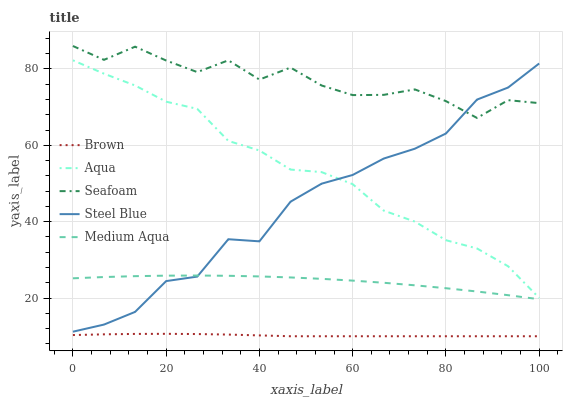Does Brown have the minimum area under the curve?
Answer yes or no. Yes. Does Seafoam have the maximum area under the curve?
Answer yes or no. Yes. Does Aqua have the minimum area under the curve?
Answer yes or no. No. Does Aqua have the maximum area under the curve?
Answer yes or no. No. Is Brown the smoothest?
Answer yes or no. Yes. Is Seafoam the roughest?
Answer yes or no. Yes. Is Aqua the smoothest?
Answer yes or no. No. Is Aqua the roughest?
Answer yes or no. No. Does Aqua have the lowest value?
Answer yes or no. No. Does Seafoam have the highest value?
Answer yes or no. Yes. Does Aqua have the highest value?
Answer yes or no. No. Is Brown less than Medium Aqua?
Answer yes or no. Yes. Is Seafoam greater than Brown?
Answer yes or no. Yes. Does Steel Blue intersect Seafoam?
Answer yes or no. Yes. Is Steel Blue less than Seafoam?
Answer yes or no. No. Is Steel Blue greater than Seafoam?
Answer yes or no. No. Does Brown intersect Medium Aqua?
Answer yes or no. No. 